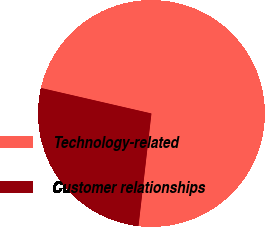<chart> <loc_0><loc_0><loc_500><loc_500><pie_chart><fcel>Technology-related<fcel>Customer relationships<nl><fcel>73.21%<fcel>26.79%<nl></chart> 